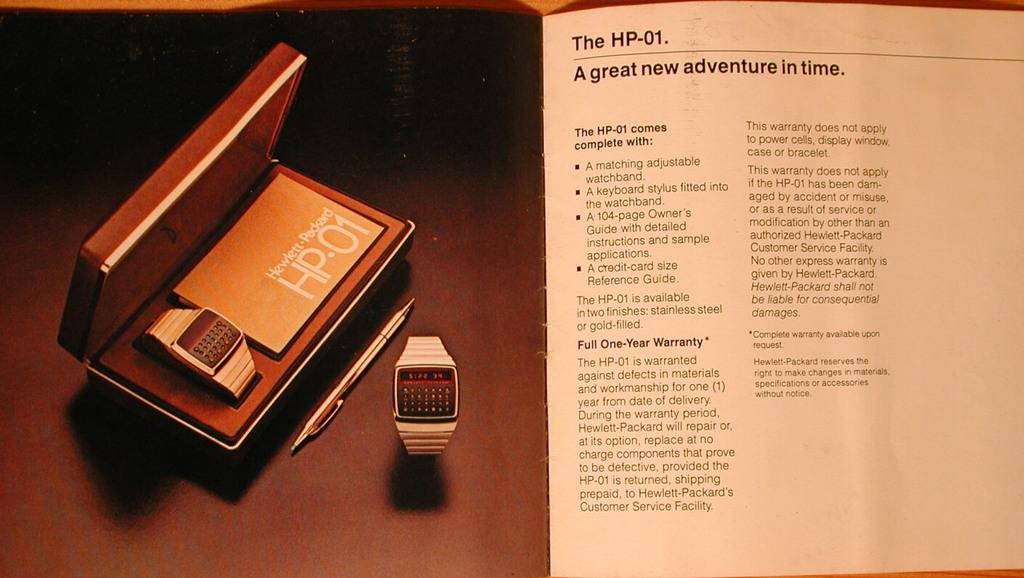<image>
Create a compact narrative representing the image presented. Two white hp01 smart watches with the box and instruction manual next to them. 